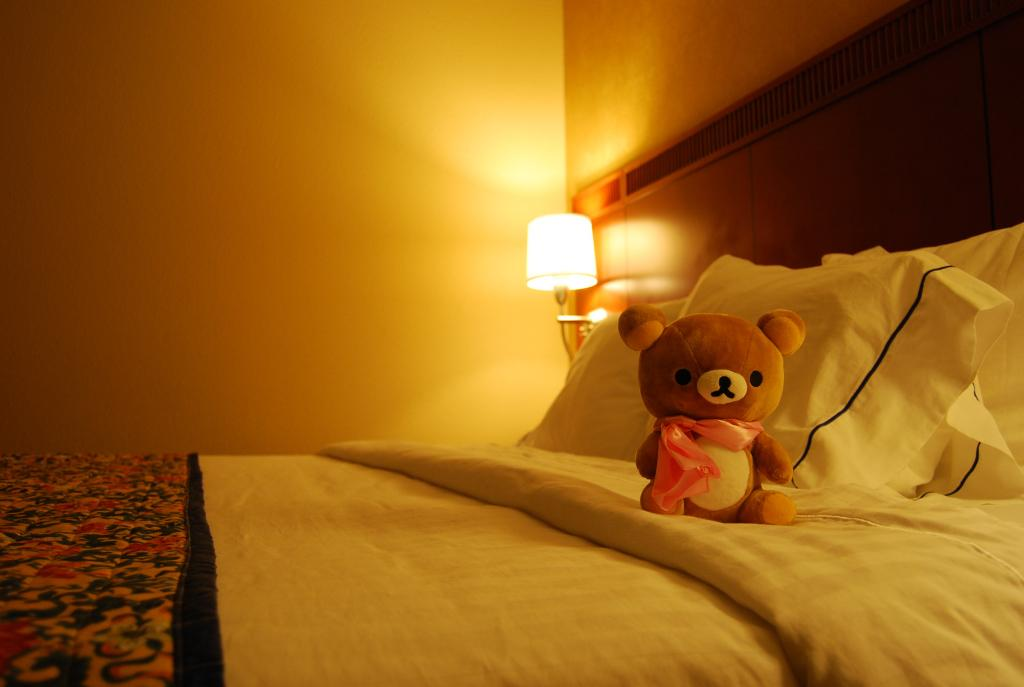What is the setting of the image? The image is inside a room. What furniture is present in the room? There is a bed in the room. What object can be seen on the bed? There is a toy on the bed. What lighting source is present in the room? There is a lamp in the room. What advice can be seen written on the wall in the image? There is no advice written on the wall in the image. Can you see the ocean from the room in the image? The image does not show any view of the ocean, as it is set inside a room. 